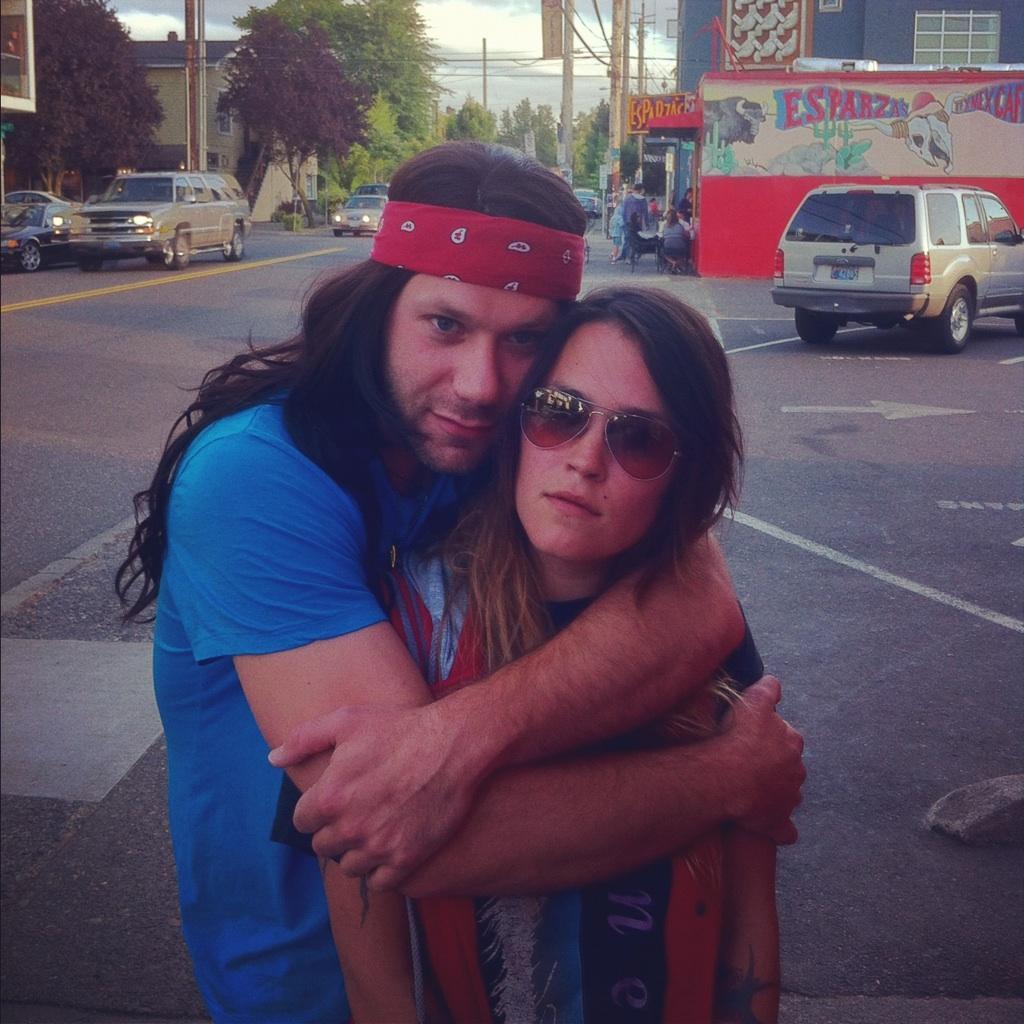Can you describe this image briefly? In this image I see a man who is hugging this woman and I see that this woman is wearing shades. In the background I see the road and I see many cars and I see few people over here and I see number of buildings, poles, trees and I see the sky. 